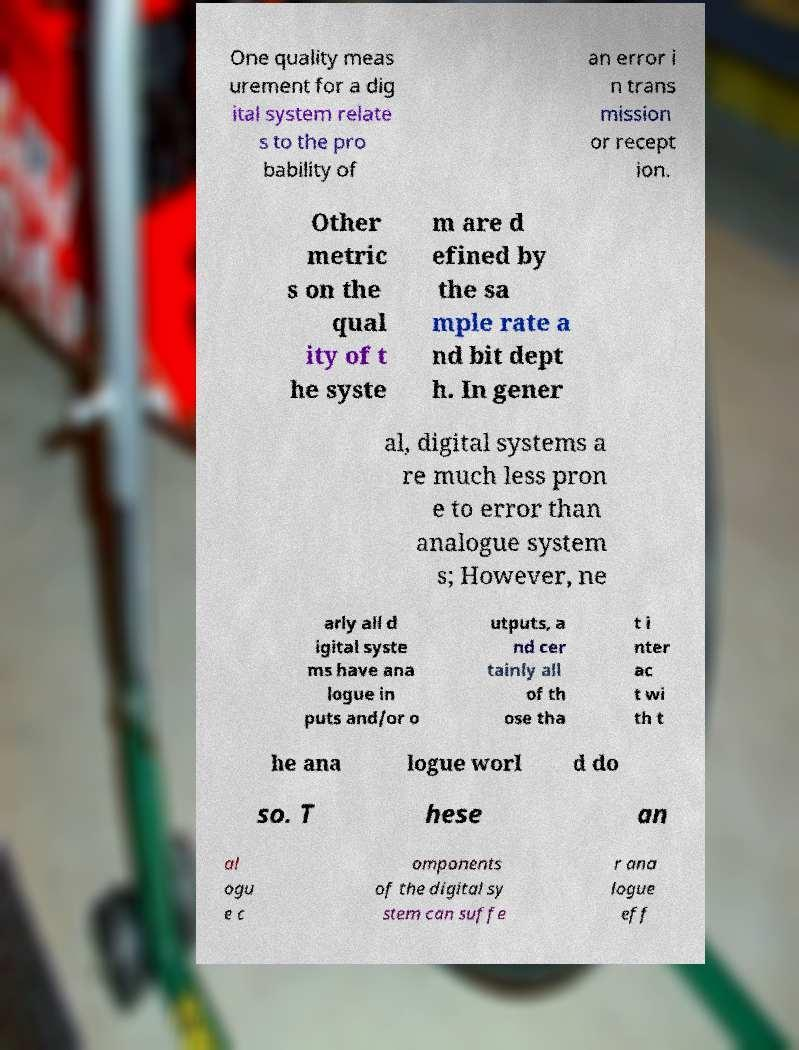Can you read and provide the text displayed in the image?This photo seems to have some interesting text. Can you extract and type it out for me? One quality meas urement for a dig ital system relate s to the pro bability of an error i n trans mission or recept ion. Other metric s on the qual ity of t he syste m are d efined by the sa mple rate a nd bit dept h. In gener al, digital systems a re much less pron e to error than analogue system s; However, ne arly all d igital syste ms have ana logue in puts and/or o utputs, a nd cer tainly all of th ose tha t i nter ac t wi th t he ana logue worl d do so. T hese an al ogu e c omponents of the digital sy stem can suffe r ana logue eff 